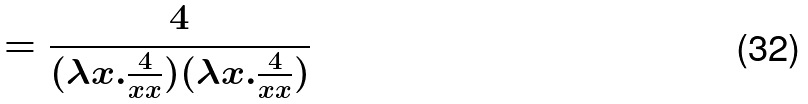Convert formula to latex. <formula><loc_0><loc_0><loc_500><loc_500>= \frac { 4 } { ( \lambda x . \frac { 4 } { x x } ) ( \lambda x . \frac { 4 } { x x } ) }</formula> 